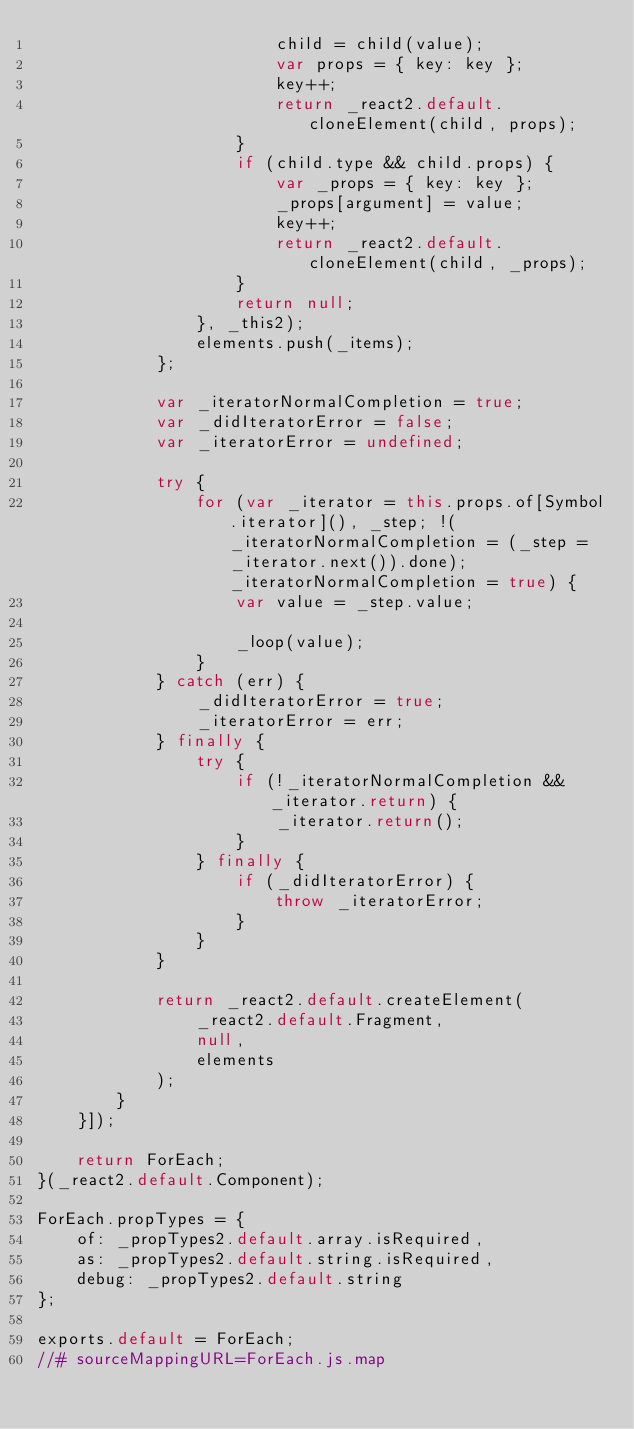<code> <loc_0><loc_0><loc_500><loc_500><_JavaScript_>                        child = child(value);
                        var props = { key: key };
                        key++;
                        return _react2.default.cloneElement(child, props);
                    }
                    if (child.type && child.props) {
                        var _props = { key: key };
                        _props[argument] = value;
                        key++;
                        return _react2.default.cloneElement(child, _props);
                    }
                    return null;
                }, _this2);
                elements.push(_items);
            };

            var _iteratorNormalCompletion = true;
            var _didIteratorError = false;
            var _iteratorError = undefined;

            try {
                for (var _iterator = this.props.of[Symbol.iterator](), _step; !(_iteratorNormalCompletion = (_step = _iterator.next()).done); _iteratorNormalCompletion = true) {
                    var value = _step.value;

                    _loop(value);
                }
            } catch (err) {
                _didIteratorError = true;
                _iteratorError = err;
            } finally {
                try {
                    if (!_iteratorNormalCompletion && _iterator.return) {
                        _iterator.return();
                    }
                } finally {
                    if (_didIteratorError) {
                        throw _iteratorError;
                    }
                }
            }

            return _react2.default.createElement(
                _react2.default.Fragment,
                null,
                elements
            );
        }
    }]);

    return ForEach;
}(_react2.default.Component);

ForEach.propTypes = {
    of: _propTypes2.default.array.isRequired,
    as: _propTypes2.default.string.isRequired,
    debug: _propTypes2.default.string
};

exports.default = ForEach;
//# sourceMappingURL=ForEach.js.map</code> 